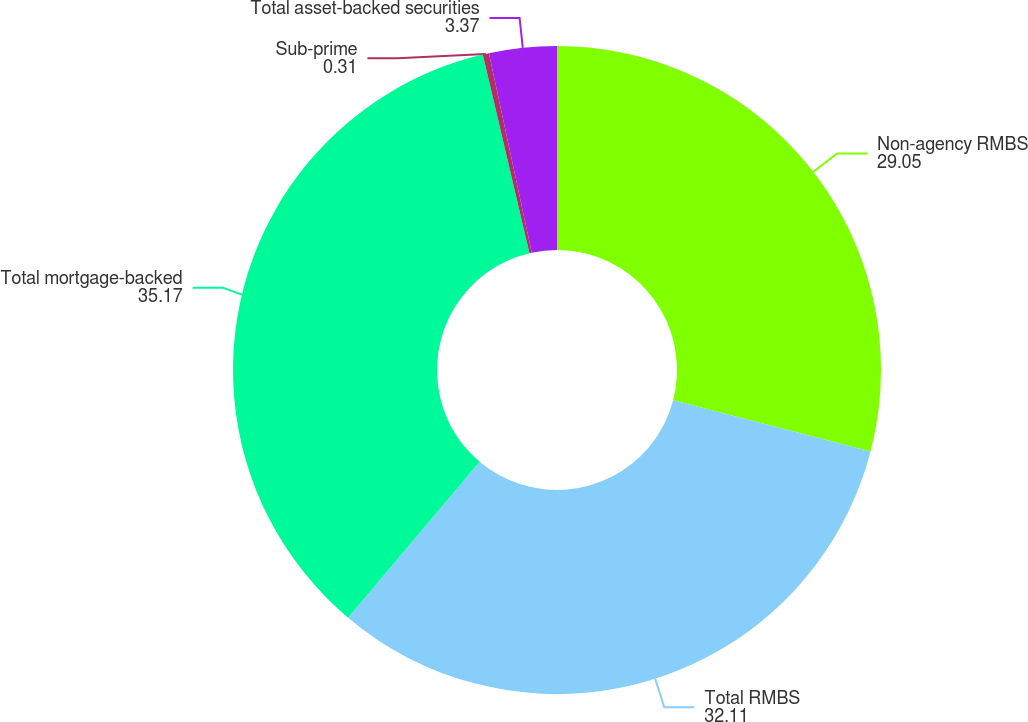Convert chart to OTSL. <chart><loc_0><loc_0><loc_500><loc_500><pie_chart><fcel>Non-agency RMBS<fcel>Total RMBS<fcel>Total mortgage-backed<fcel>Sub-prime<fcel>Total asset-backed securities<nl><fcel>29.05%<fcel>32.11%<fcel>35.17%<fcel>0.31%<fcel>3.37%<nl></chart> 